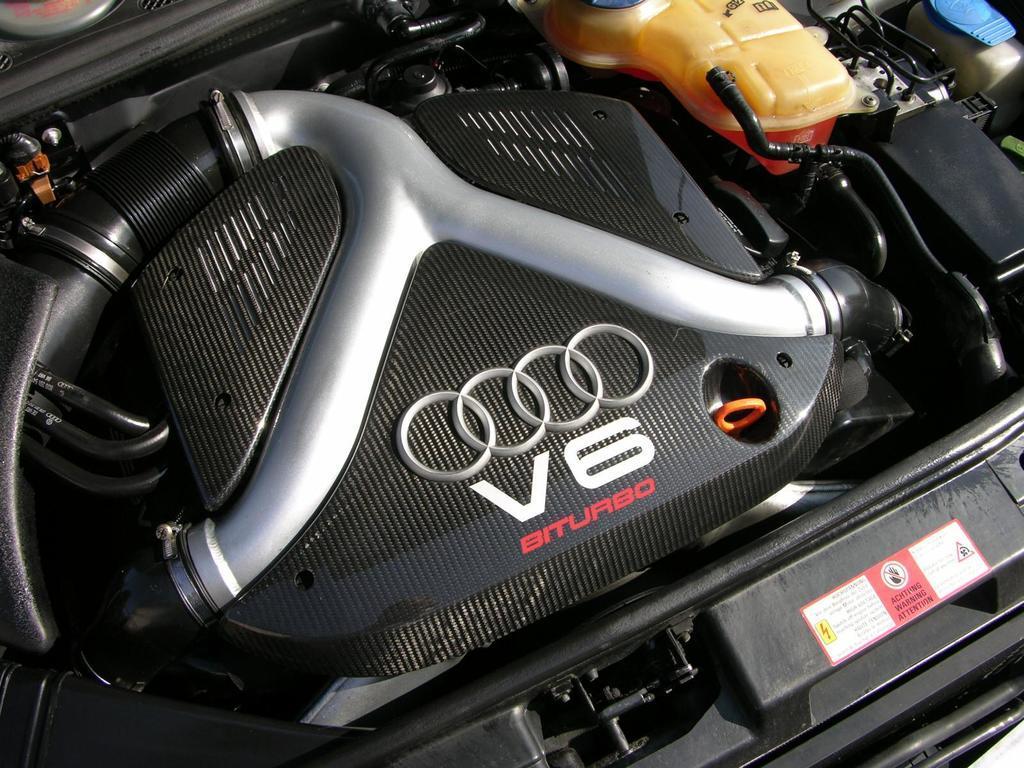Could you give a brief overview of what you see in this image? In this image I can see a parts of the car. 